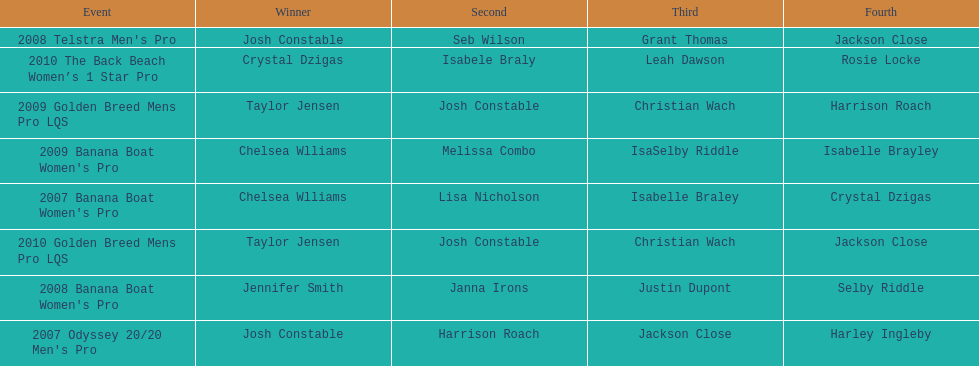I'm looking to parse the entire table for insights. Could you assist me with that? {'header': ['Event', 'Winner', 'Second', 'Third', 'Fourth'], 'rows': [["2008 Telstra Men's Pro", 'Josh Constable', 'Seb Wilson', 'Grant Thomas', 'Jackson Close'], ['2010 The Back Beach Women’s 1 Star Pro', 'Crystal Dzigas', 'Isabele Braly', 'Leah Dawson', 'Rosie Locke'], ['2009 Golden Breed Mens Pro LQS', 'Taylor Jensen', 'Josh Constable', 'Christian Wach', 'Harrison Roach'], ["2009 Banana Boat Women's Pro", 'Chelsea Wlliams', 'Melissa Combo', 'IsaSelby Riddle', 'Isabelle Brayley'], ["2007 Banana Boat Women's Pro", 'Chelsea Wlliams', 'Lisa Nicholson', 'Isabelle Braley', 'Crystal Dzigas'], ['2010 Golden Breed Mens Pro LQS', 'Taylor Jensen', 'Josh Constable', 'Christian Wach', 'Jackson Close'], ["2008 Banana Boat Women's Pro", 'Jennifer Smith', 'Janna Irons', 'Justin Dupont', 'Selby Riddle'], ["2007 Odyssey 20/20 Men's Pro", 'Josh Constable', 'Harrison Roach', 'Jackson Close', 'Harley Ingleby']]} In what two races did chelsea williams earn the same rank? 2007 Banana Boat Women's Pro, 2009 Banana Boat Women's Pro. 